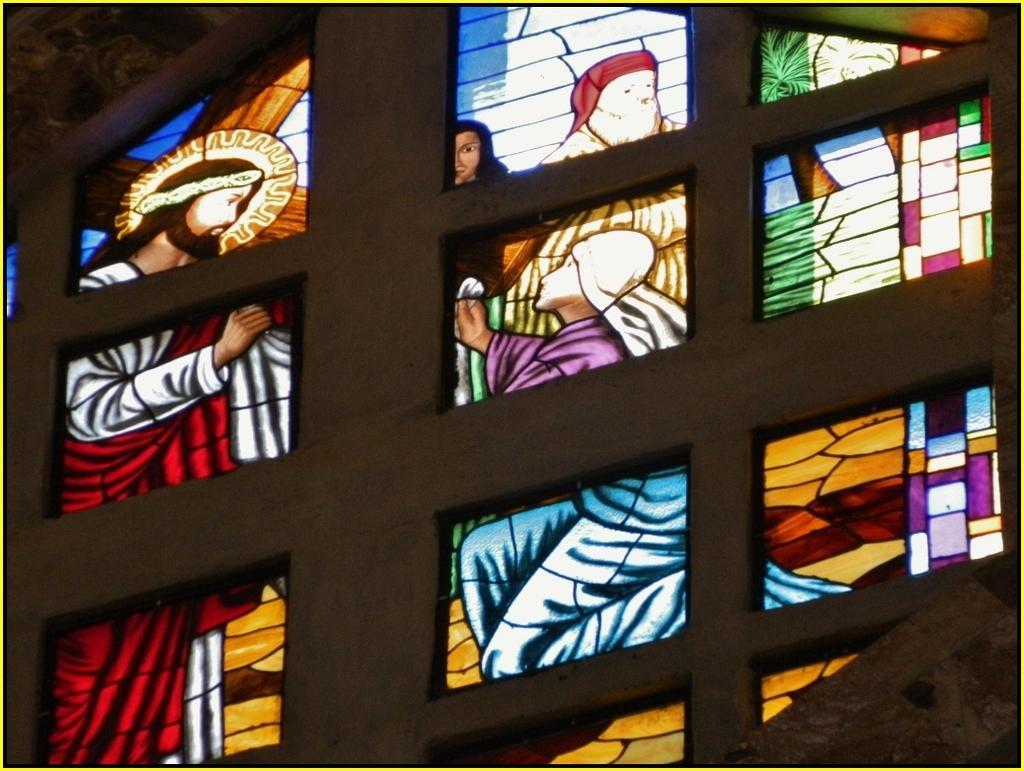Can you describe this image briefly? In the picture we can see inside part of the church view with a glass wall with the paintings of Jesus an some people and some frames to the glass. 